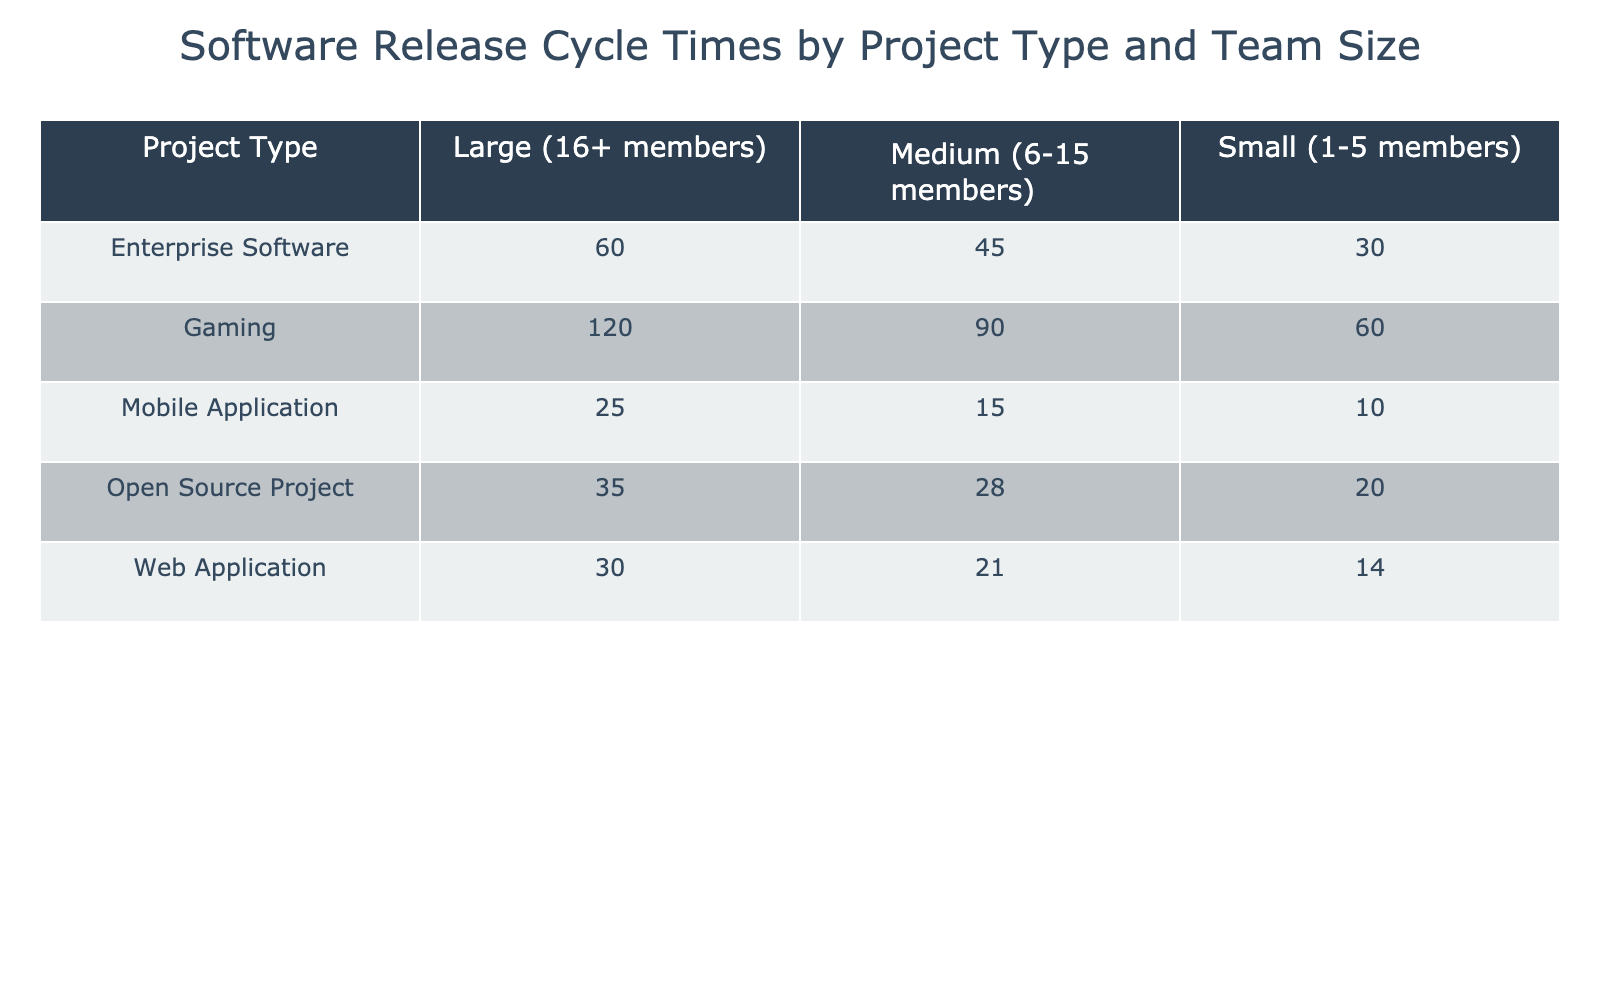What is the release cycle time for a Mobile Application with a Medium team size? The table shows that for the "Mobile Application" with "Medium (6-15 members)" team size, the Average Release Cycle Time is 15 days.
Answer: 15 days Which project type has the highest average release cycle time for a Small team size? Looking at the table, the "Gaming" project type has the highest Average Release Cycle Time of 60 days for the "Small (1-5 members)" team size compared to other project types.
Answer: Gaming What is the total average release cycle time for Large projects across all project types? To find this, I sum the release cycle times for Large projects: Web Application (30) + Mobile Application (25) + Enterprise Software (60) + Open Source Project (35) + Gaming (120) = 30 + 25 + 60 + 35 + 120 = 270 days.
Answer: 270 days Is the average release cycle time for Medium-sized teams in Open Source Projects less than that of Gaming projects? According to the table, Open Source projects have an average release cycle time of 28 days for Medium teams, while Gaming projects have 90 days. Since 28 is less than 90, the statement is true.
Answer: Yes What project type has the smallest average release cycle time for a Large team size? We look at the Large team size column across all project types: Web Application (30), Mobile Application (25), Enterprise Software (60), Open Source Project (35), Gaming (120). The Smallest Average Release Cycle Time among these values is 25 days for the Mobile Application.
Answer: Mobile Application What is the difference in average release cycle time between Small and Large teams for Enterprise Software? For Enterprise Software, the average for Small teams is 30 days and for Large teams, it is 60 days. The difference is calculated as 60 - 30 = 30 days.
Answer: 30 days For which project type does a Medium-sized team have the shortest release cycle time? In the table under Medium teams, Web Application (21), Mobile Application (15), Enterprise Software (45), Open Source Project (28), and Gaming (90) are listed. The shortest time is found with the Mobile Application at 15 days.
Answer: Mobile Application Is it true that all project types have a longer average release cycle time for Large teams compared to Small teams? By checking the table: Web Application (30 vs 14), Mobile Application (25 vs 10), Enterprise Software (60 vs 30), Open Source Project (35 vs 20), and Gaming (120 vs 60), each Large team's time is greater than that of Small teams, confirming this statement as true.
Answer: Yes 